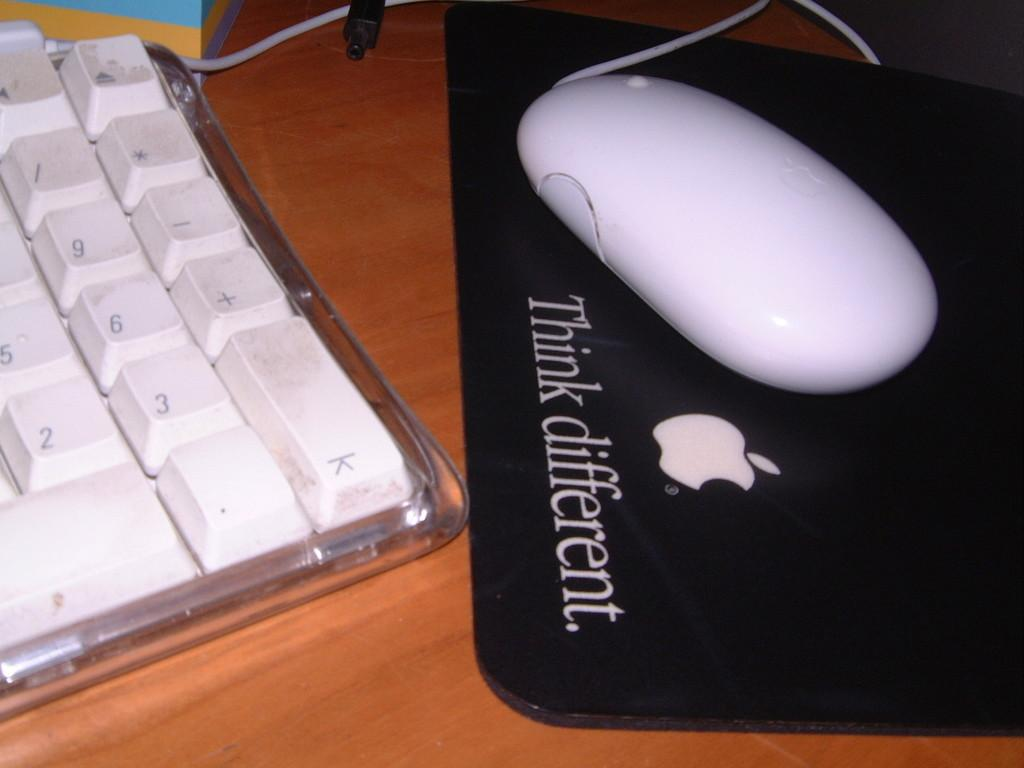<image>
Offer a succinct explanation of the picture presented. A white keyboard , a white mouse and a black mouse pad that states Think Different. 